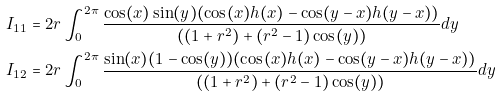Convert formula to latex. <formula><loc_0><loc_0><loc_500><loc_500>I _ { 1 1 } & = 2 r \int _ { 0 } ^ { 2 \pi } \frac { \cos ( x ) \sin ( y ) ( \cos ( x ) h ( x ) - \cos ( y - x ) h ( y - x ) ) } { ( ( 1 + r ^ { 2 } ) + ( r ^ { 2 } - 1 ) \cos ( y ) ) } d y \\ I _ { 1 2 } & = 2 r \int _ { 0 } ^ { 2 \pi } \frac { \sin ( x ) ( 1 - \cos ( y ) ) ( \cos ( x ) h ( x ) - \cos ( y - x ) h ( y - x ) ) } { ( ( 1 + r ^ { 2 } ) + ( r ^ { 2 } - 1 ) \cos ( y ) ) } d y \\</formula> 